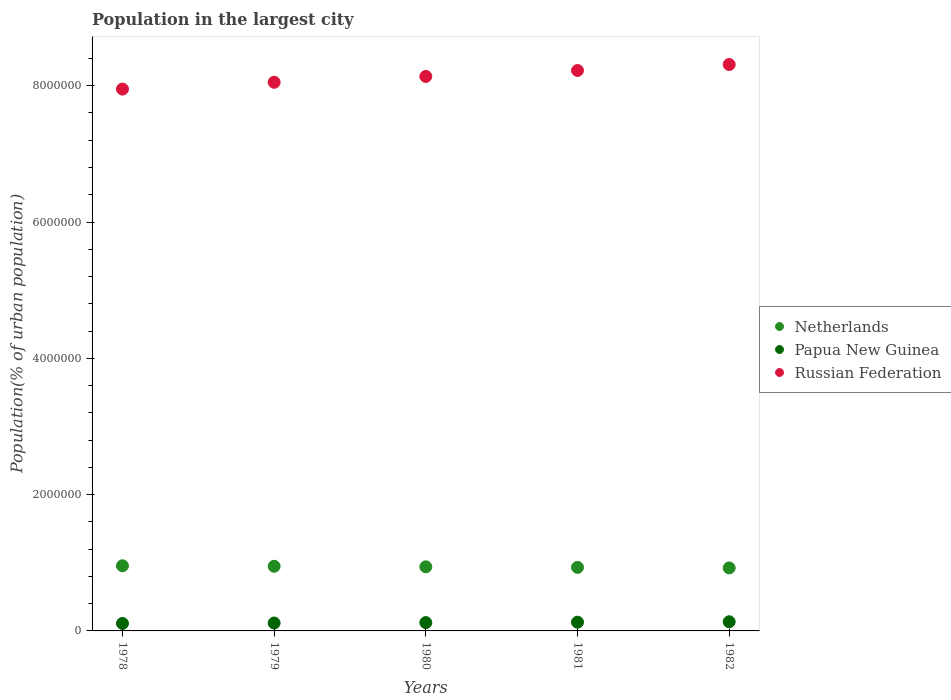What is the population in the largest city in Papua New Guinea in 1980?
Offer a very short reply. 1.22e+05. Across all years, what is the maximum population in the largest city in Netherlands?
Your answer should be compact. 9.56e+05. Across all years, what is the minimum population in the largest city in Netherlands?
Provide a short and direct response. 9.24e+05. In which year was the population in the largest city in Papua New Guinea minimum?
Provide a short and direct response. 1978. What is the total population in the largest city in Papua New Guinea in the graph?
Offer a very short reply. 6.11e+05. What is the difference between the population in the largest city in Russian Federation in 1978 and that in 1981?
Offer a terse response. -2.73e+05. What is the difference between the population in the largest city in Papua New Guinea in 1980 and the population in the largest city in Russian Federation in 1982?
Make the answer very short. -8.19e+06. What is the average population in the largest city in Netherlands per year?
Your answer should be compact. 9.40e+05. In the year 1978, what is the difference between the population in the largest city in Russian Federation and population in the largest city in Netherlands?
Provide a short and direct response. 6.99e+06. What is the ratio of the population in the largest city in Netherlands in 1979 to that in 1981?
Provide a succinct answer. 1.02. Is the population in the largest city in Netherlands in 1978 less than that in 1979?
Keep it short and to the point. No. Is the difference between the population in the largest city in Russian Federation in 1978 and 1980 greater than the difference between the population in the largest city in Netherlands in 1978 and 1980?
Your answer should be very brief. No. What is the difference between the highest and the second highest population in the largest city in Netherlands?
Provide a short and direct response. 7426. What is the difference between the highest and the lowest population in the largest city in Netherlands?
Provide a short and direct response. 3.15e+04. Is the sum of the population in the largest city in Netherlands in 1980 and 1981 greater than the maximum population in the largest city in Russian Federation across all years?
Offer a terse response. No. Does the population in the largest city in Russian Federation monotonically increase over the years?
Your answer should be compact. Yes. Is the population in the largest city in Netherlands strictly less than the population in the largest city in Russian Federation over the years?
Provide a succinct answer. Yes. Are the values on the major ticks of Y-axis written in scientific E-notation?
Offer a very short reply. No. Does the graph contain any zero values?
Your answer should be very brief. No. Does the graph contain grids?
Your response must be concise. No. How are the legend labels stacked?
Your answer should be compact. Vertical. What is the title of the graph?
Your answer should be compact. Population in the largest city. What is the label or title of the Y-axis?
Ensure brevity in your answer.  Population(% of urban population). What is the Population(% of urban population) in Netherlands in 1978?
Your answer should be compact. 9.56e+05. What is the Population(% of urban population) of Papua New Guinea in 1978?
Your answer should be compact. 1.10e+05. What is the Population(% of urban population) of Russian Federation in 1978?
Provide a short and direct response. 7.95e+06. What is the Population(% of urban population) of Netherlands in 1979?
Keep it short and to the point. 9.48e+05. What is the Population(% of urban population) of Papua New Guinea in 1979?
Ensure brevity in your answer.  1.16e+05. What is the Population(% of urban population) of Russian Federation in 1979?
Offer a very short reply. 8.05e+06. What is the Population(% of urban population) of Netherlands in 1980?
Give a very brief answer. 9.41e+05. What is the Population(% of urban population) in Papua New Guinea in 1980?
Your response must be concise. 1.22e+05. What is the Population(% of urban population) of Russian Federation in 1980?
Make the answer very short. 8.14e+06. What is the Population(% of urban population) in Netherlands in 1981?
Give a very brief answer. 9.32e+05. What is the Population(% of urban population) in Papua New Guinea in 1981?
Offer a terse response. 1.28e+05. What is the Population(% of urban population) in Russian Federation in 1981?
Provide a short and direct response. 8.22e+06. What is the Population(% of urban population) of Netherlands in 1982?
Provide a succinct answer. 9.24e+05. What is the Population(% of urban population) of Papua New Guinea in 1982?
Your answer should be compact. 1.34e+05. What is the Population(% of urban population) in Russian Federation in 1982?
Offer a terse response. 8.31e+06. Across all years, what is the maximum Population(% of urban population) of Netherlands?
Ensure brevity in your answer.  9.56e+05. Across all years, what is the maximum Population(% of urban population) of Papua New Guinea?
Provide a short and direct response. 1.34e+05. Across all years, what is the maximum Population(% of urban population) of Russian Federation?
Keep it short and to the point. 8.31e+06. Across all years, what is the minimum Population(% of urban population) in Netherlands?
Give a very brief answer. 9.24e+05. Across all years, what is the minimum Population(% of urban population) in Papua New Guinea?
Make the answer very short. 1.10e+05. Across all years, what is the minimum Population(% of urban population) of Russian Federation?
Offer a terse response. 7.95e+06. What is the total Population(% of urban population) in Netherlands in the graph?
Offer a terse response. 4.70e+06. What is the total Population(% of urban population) of Papua New Guinea in the graph?
Your answer should be very brief. 6.11e+05. What is the total Population(% of urban population) of Russian Federation in the graph?
Keep it short and to the point. 4.07e+07. What is the difference between the Population(% of urban population) in Netherlands in 1978 and that in 1979?
Your response must be concise. 7426. What is the difference between the Population(% of urban population) of Papua New Guinea in 1978 and that in 1979?
Provide a succinct answer. -5887. What is the difference between the Population(% of urban population) in Russian Federation in 1978 and that in 1979?
Your response must be concise. -9.98e+04. What is the difference between the Population(% of urban population) of Netherlands in 1978 and that in 1980?
Give a very brief answer. 1.52e+04. What is the difference between the Population(% of urban population) of Papua New Guinea in 1978 and that in 1980?
Your answer should be compact. -1.21e+04. What is the difference between the Population(% of urban population) in Russian Federation in 1978 and that in 1980?
Your response must be concise. -1.86e+05. What is the difference between the Population(% of urban population) of Netherlands in 1978 and that in 1981?
Your response must be concise. 2.34e+04. What is the difference between the Population(% of urban population) of Papua New Guinea in 1978 and that in 1981?
Make the answer very short. -1.81e+04. What is the difference between the Population(% of urban population) of Russian Federation in 1978 and that in 1981?
Your answer should be compact. -2.73e+05. What is the difference between the Population(% of urban population) in Netherlands in 1978 and that in 1982?
Provide a short and direct response. 3.15e+04. What is the difference between the Population(% of urban population) of Papua New Guinea in 1978 and that in 1982?
Offer a very short reply. -2.42e+04. What is the difference between the Population(% of urban population) of Russian Federation in 1978 and that in 1982?
Provide a short and direct response. -3.60e+05. What is the difference between the Population(% of urban population) in Netherlands in 1979 and that in 1980?
Ensure brevity in your answer.  7805. What is the difference between the Population(% of urban population) of Papua New Guinea in 1979 and that in 1980?
Provide a succinct answer. -6209. What is the difference between the Population(% of urban population) of Russian Federation in 1979 and that in 1980?
Your response must be concise. -8.61e+04. What is the difference between the Population(% of urban population) of Netherlands in 1979 and that in 1981?
Offer a terse response. 1.60e+04. What is the difference between the Population(% of urban population) of Papua New Guinea in 1979 and that in 1981?
Offer a terse response. -1.22e+04. What is the difference between the Population(% of urban population) in Russian Federation in 1979 and that in 1981?
Keep it short and to the point. -1.73e+05. What is the difference between the Population(% of urban population) in Netherlands in 1979 and that in 1982?
Offer a very short reply. 2.40e+04. What is the difference between the Population(% of urban population) in Papua New Guinea in 1979 and that in 1982?
Offer a terse response. -1.84e+04. What is the difference between the Population(% of urban population) in Russian Federation in 1979 and that in 1982?
Your answer should be very brief. -2.61e+05. What is the difference between the Population(% of urban population) of Netherlands in 1980 and that in 1981?
Offer a terse response. 8148. What is the difference between the Population(% of urban population) in Papua New Guinea in 1980 and that in 1981?
Offer a terse response. -6000. What is the difference between the Population(% of urban population) in Russian Federation in 1980 and that in 1981?
Offer a terse response. -8.68e+04. What is the difference between the Population(% of urban population) in Netherlands in 1980 and that in 1982?
Your answer should be compact. 1.62e+04. What is the difference between the Population(% of urban population) in Papua New Guinea in 1980 and that in 1982?
Your answer should be compact. -1.21e+04. What is the difference between the Population(% of urban population) in Russian Federation in 1980 and that in 1982?
Offer a very short reply. -1.75e+05. What is the difference between the Population(% of urban population) of Netherlands in 1981 and that in 1982?
Provide a succinct answer. 8088. What is the difference between the Population(% of urban population) in Papua New Guinea in 1981 and that in 1982?
Provide a succinct answer. -6142. What is the difference between the Population(% of urban population) of Russian Federation in 1981 and that in 1982?
Your response must be concise. -8.78e+04. What is the difference between the Population(% of urban population) of Netherlands in 1978 and the Population(% of urban population) of Papua New Guinea in 1979?
Offer a very short reply. 8.40e+05. What is the difference between the Population(% of urban population) in Netherlands in 1978 and the Population(% of urban population) in Russian Federation in 1979?
Make the answer very short. -7.09e+06. What is the difference between the Population(% of urban population) of Papua New Guinea in 1978 and the Population(% of urban population) of Russian Federation in 1979?
Give a very brief answer. -7.94e+06. What is the difference between the Population(% of urban population) of Netherlands in 1978 and the Population(% of urban population) of Papua New Guinea in 1980?
Keep it short and to the point. 8.34e+05. What is the difference between the Population(% of urban population) in Netherlands in 1978 and the Population(% of urban population) in Russian Federation in 1980?
Your response must be concise. -7.18e+06. What is the difference between the Population(% of urban population) of Papua New Guinea in 1978 and the Population(% of urban population) of Russian Federation in 1980?
Offer a very short reply. -8.03e+06. What is the difference between the Population(% of urban population) in Netherlands in 1978 and the Population(% of urban population) in Papua New Guinea in 1981?
Give a very brief answer. 8.28e+05. What is the difference between the Population(% of urban population) of Netherlands in 1978 and the Population(% of urban population) of Russian Federation in 1981?
Your answer should be very brief. -7.27e+06. What is the difference between the Population(% of urban population) of Papua New Guinea in 1978 and the Population(% of urban population) of Russian Federation in 1981?
Your response must be concise. -8.11e+06. What is the difference between the Population(% of urban population) of Netherlands in 1978 and the Population(% of urban population) of Papua New Guinea in 1982?
Provide a succinct answer. 8.22e+05. What is the difference between the Population(% of urban population) of Netherlands in 1978 and the Population(% of urban population) of Russian Federation in 1982?
Give a very brief answer. -7.35e+06. What is the difference between the Population(% of urban population) in Papua New Guinea in 1978 and the Population(% of urban population) in Russian Federation in 1982?
Your answer should be very brief. -8.20e+06. What is the difference between the Population(% of urban population) of Netherlands in 1979 and the Population(% of urban population) of Papua New Guinea in 1980?
Ensure brevity in your answer.  8.26e+05. What is the difference between the Population(% of urban population) in Netherlands in 1979 and the Population(% of urban population) in Russian Federation in 1980?
Your answer should be very brief. -7.19e+06. What is the difference between the Population(% of urban population) of Papua New Guinea in 1979 and the Population(% of urban population) of Russian Federation in 1980?
Your answer should be compact. -8.02e+06. What is the difference between the Population(% of urban population) in Netherlands in 1979 and the Population(% of urban population) in Papua New Guinea in 1981?
Ensure brevity in your answer.  8.20e+05. What is the difference between the Population(% of urban population) in Netherlands in 1979 and the Population(% of urban population) in Russian Federation in 1981?
Your answer should be very brief. -7.27e+06. What is the difference between the Population(% of urban population) of Papua New Guinea in 1979 and the Population(% of urban population) of Russian Federation in 1981?
Offer a terse response. -8.11e+06. What is the difference between the Population(% of urban population) of Netherlands in 1979 and the Population(% of urban population) of Papua New Guinea in 1982?
Ensure brevity in your answer.  8.14e+05. What is the difference between the Population(% of urban population) in Netherlands in 1979 and the Population(% of urban population) in Russian Federation in 1982?
Your answer should be very brief. -7.36e+06. What is the difference between the Population(% of urban population) of Papua New Guinea in 1979 and the Population(% of urban population) of Russian Federation in 1982?
Provide a succinct answer. -8.19e+06. What is the difference between the Population(% of urban population) of Netherlands in 1980 and the Population(% of urban population) of Papua New Guinea in 1981?
Offer a very short reply. 8.12e+05. What is the difference between the Population(% of urban population) in Netherlands in 1980 and the Population(% of urban population) in Russian Federation in 1981?
Offer a terse response. -7.28e+06. What is the difference between the Population(% of urban population) in Papua New Guinea in 1980 and the Population(% of urban population) in Russian Federation in 1981?
Your response must be concise. -8.10e+06. What is the difference between the Population(% of urban population) in Netherlands in 1980 and the Population(% of urban population) in Papua New Guinea in 1982?
Offer a very short reply. 8.06e+05. What is the difference between the Population(% of urban population) of Netherlands in 1980 and the Population(% of urban population) of Russian Federation in 1982?
Offer a terse response. -7.37e+06. What is the difference between the Population(% of urban population) in Papua New Guinea in 1980 and the Population(% of urban population) in Russian Federation in 1982?
Provide a succinct answer. -8.19e+06. What is the difference between the Population(% of urban population) in Netherlands in 1981 and the Population(% of urban population) in Papua New Guinea in 1982?
Keep it short and to the point. 7.98e+05. What is the difference between the Population(% of urban population) of Netherlands in 1981 and the Population(% of urban population) of Russian Federation in 1982?
Your answer should be compact. -7.38e+06. What is the difference between the Population(% of urban population) in Papua New Guinea in 1981 and the Population(% of urban population) in Russian Federation in 1982?
Give a very brief answer. -8.18e+06. What is the average Population(% of urban population) of Netherlands per year?
Ensure brevity in your answer.  9.40e+05. What is the average Population(% of urban population) in Papua New Guinea per year?
Provide a short and direct response. 1.22e+05. What is the average Population(% of urban population) in Russian Federation per year?
Provide a succinct answer. 8.13e+06. In the year 1978, what is the difference between the Population(% of urban population) of Netherlands and Population(% of urban population) of Papua New Guinea?
Your response must be concise. 8.46e+05. In the year 1978, what is the difference between the Population(% of urban population) in Netherlands and Population(% of urban population) in Russian Federation?
Keep it short and to the point. -6.99e+06. In the year 1978, what is the difference between the Population(% of urban population) of Papua New Guinea and Population(% of urban population) of Russian Federation?
Ensure brevity in your answer.  -7.84e+06. In the year 1979, what is the difference between the Population(% of urban population) of Netherlands and Population(% of urban population) of Papua New Guinea?
Your answer should be very brief. 8.32e+05. In the year 1979, what is the difference between the Population(% of urban population) of Netherlands and Population(% of urban population) of Russian Federation?
Keep it short and to the point. -7.10e+06. In the year 1979, what is the difference between the Population(% of urban population) of Papua New Guinea and Population(% of urban population) of Russian Federation?
Keep it short and to the point. -7.93e+06. In the year 1980, what is the difference between the Population(% of urban population) of Netherlands and Population(% of urban population) of Papua New Guinea?
Offer a very short reply. 8.18e+05. In the year 1980, what is the difference between the Population(% of urban population) in Netherlands and Population(% of urban population) in Russian Federation?
Your answer should be compact. -7.20e+06. In the year 1980, what is the difference between the Population(% of urban population) in Papua New Guinea and Population(% of urban population) in Russian Federation?
Provide a short and direct response. -8.01e+06. In the year 1981, what is the difference between the Population(% of urban population) of Netherlands and Population(% of urban population) of Papua New Guinea?
Your answer should be compact. 8.04e+05. In the year 1981, what is the difference between the Population(% of urban population) in Netherlands and Population(% of urban population) in Russian Federation?
Give a very brief answer. -7.29e+06. In the year 1981, what is the difference between the Population(% of urban population) of Papua New Guinea and Population(% of urban population) of Russian Federation?
Keep it short and to the point. -8.09e+06. In the year 1982, what is the difference between the Population(% of urban population) in Netherlands and Population(% of urban population) in Papua New Guinea?
Offer a terse response. 7.90e+05. In the year 1982, what is the difference between the Population(% of urban population) of Netherlands and Population(% of urban population) of Russian Federation?
Ensure brevity in your answer.  -7.39e+06. In the year 1982, what is the difference between the Population(% of urban population) of Papua New Guinea and Population(% of urban population) of Russian Federation?
Keep it short and to the point. -8.18e+06. What is the ratio of the Population(% of urban population) in Netherlands in 1978 to that in 1979?
Your response must be concise. 1.01. What is the ratio of the Population(% of urban population) in Papua New Guinea in 1978 to that in 1979?
Offer a very short reply. 0.95. What is the ratio of the Population(% of urban population) of Russian Federation in 1978 to that in 1979?
Provide a short and direct response. 0.99. What is the ratio of the Population(% of urban population) in Netherlands in 1978 to that in 1980?
Give a very brief answer. 1.02. What is the ratio of the Population(% of urban population) of Papua New Guinea in 1978 to that in 1980?
Make the answer very short. 0.9. What is the ratio of the Population(% of urban population) of Russian Federation in 1978 to that in 1980?
Keep it short and to the point. 0.98. What is the ratio of the Population(% of urban population) of Netherlands in 1978 to that in 1981?
Your answer should be compact. 1.03. What is the ratio of the Population(% of urban population) in Papua New Guinea in 1978 to that in 1981?
Provide a short and direct response. 0.86. What is the ratio of the Population(% of urban population) in Russian Federation in 1978 to that in 1981?
Your answer should be compact. 0.97. What is the ratio of the Population(% of urban population) of Netherlands in 1978 to that in 1982?
Keep it short and to the point. 1.03. What is the ratio of the Population(% of urban population) in Papua New Guinea in 1978 to that in 1982?
Keep it short and to the point. 0.82. What is the ratio of the Population(% of urban population) in Russian Federation in 1978 to that in 1982?
Offer a terse response. 0.96. What is the ratio of the Population(% of urban population) in Netherlands in 1979 to that in 1980?
Provide a short and direct response. 1.01. What is the ratio of the Population(% of urban population) in Papua New Guinea in 1979 to that in 1980?
Ensure brevity in your answer.  0.95. What is the ratio of the Population(% of urban population) in Netherlands in 1979 to that in 1981?
Offer a terse response. 1.02. What is the ratio of the Population(% of urban population) in Papua New Guinea in 1979 to that in 1981?
Give a very brief answer. 0.9. What is the ratio of the Population(% of urban population) of Papua New Guinea in 1979 to that in 1982?
Offer a very short reply. 0.86. What is the ratio of the Population(% of urban population) in Russian Federation in 1979 to that in 1982?
Give a very brief answer. 0.97. What is the ratio of the Population(% of urban population) of Netherlands in 1980 to that in 1981?
Your answer should be compact. 1.01. What is the ratio of the Population(% of urban population) of Papua New Guinea in 1980 to that in 1981?
Ensure brevity in your answer.  0.95. What is the ratio of the Population(% of urban population) in Netherlands in 1980 to that in 1982?
Give a very brief answer. 1.02. What is the ratio of the Population(% of urban population) in Papua New Guinea in 1980 to that in 1982?
Your answer should be very brief. 0.91. What is the ratio of the Population(% of urban population) of Netherlands in 1981 to that in 1982?
Provide a succinct answer. 1.01. What is the ratio of the Population(% of urban population) of Papua New Guinea in 1981 to that in 1982?
Provide a succinct answer. 0.95. What is the difference between the highest and the second highest Population(% of urban population) in Netherlands?
Your answer should be compact. 7426. What is the difference between the highest and the second highest Population(% of urban population) in Papua New Guinea?
Keep it short and to the point. 6142. What is the difference between the highest and the second highest Population(% of urban population) in Russian Federation?
Offer a terse response. 8.78e+04. What is the difference between the highest and the lowest Population(% of urban population) of Netherlands?
Keep it short and to the point. 3.15e+04. What is the difference between the highest and the lowest Population(% of urban population) of Papua New Guinea?
Provide a short and direct response. 2.42e+04. What is the difference between the highest and the lowest Population(% of urban population) in Russian Federation?
Your answer should be compact. 3.60e+05. 